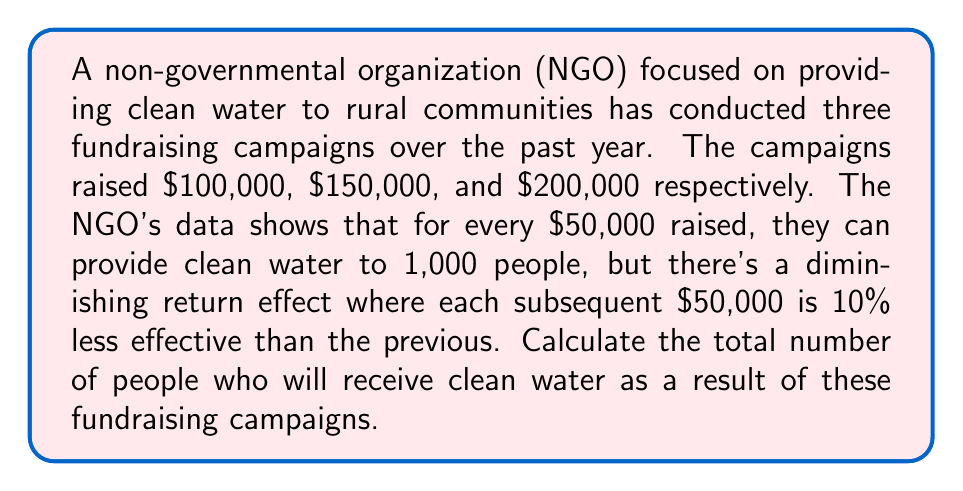What is the answer to this math problem? Let's approach this problem step-by-step:

1) First, let's define our variables:
   $x_i$ = number of people reached per $50,000 in the $i$-th $50,000 increment
   $x_1 = 1000$ (given in the problem statement)

2) We can express the diminishing return effect as:
   $x_{i+1} = 0.9 \cdot x_i$

3) Now, let's calculate the number of people reached for each $50,000 increment:
   $x_1 = 1000$
   $x_2 = 0.9 \cdot 1000 = 900$
   $x_3 = 0.9 \cdot 900 = 810$
   $x_4 = 0.9 \cdot 810 = 729$
   $x_5 = 0.9 \cdot 729 = 656.1$
   $x_6 = 0.9 \cdot 656.1 = 590.49$
   $x_7 = 0.9 \cdot 590.49 = 531.441$
   $x_8 = 0.9 \cdot 531.441 = 478.2969$
   $x_9 = 0.9 \cdot 478.2969 = 430.46721$

4) The total amount raised is $100,000 + $150,000 + $200,000 = $450,000, which is equivalent to 9 increments of $50,000.

5) To get the total number of people reached, we sum up the first 9 terms:

   $$\text{Total} = \sum_{i=1}^{9} x_i = 1000 + 900 + 810 + 729 + 656.1 + 590.49 + 531.441 + 478.2969 + 430.46721$$

6) Calculating this sum:
   $$\text{Total} = 6125.79511$$

7) Rounding to the nearest whole number (as we can't reach a fraction of a person):
   $$\text{Total} \approx 6126 \text{ people}$$
Answer: The fundraising campaigns will provide clean water to approximately 6,126 people. 